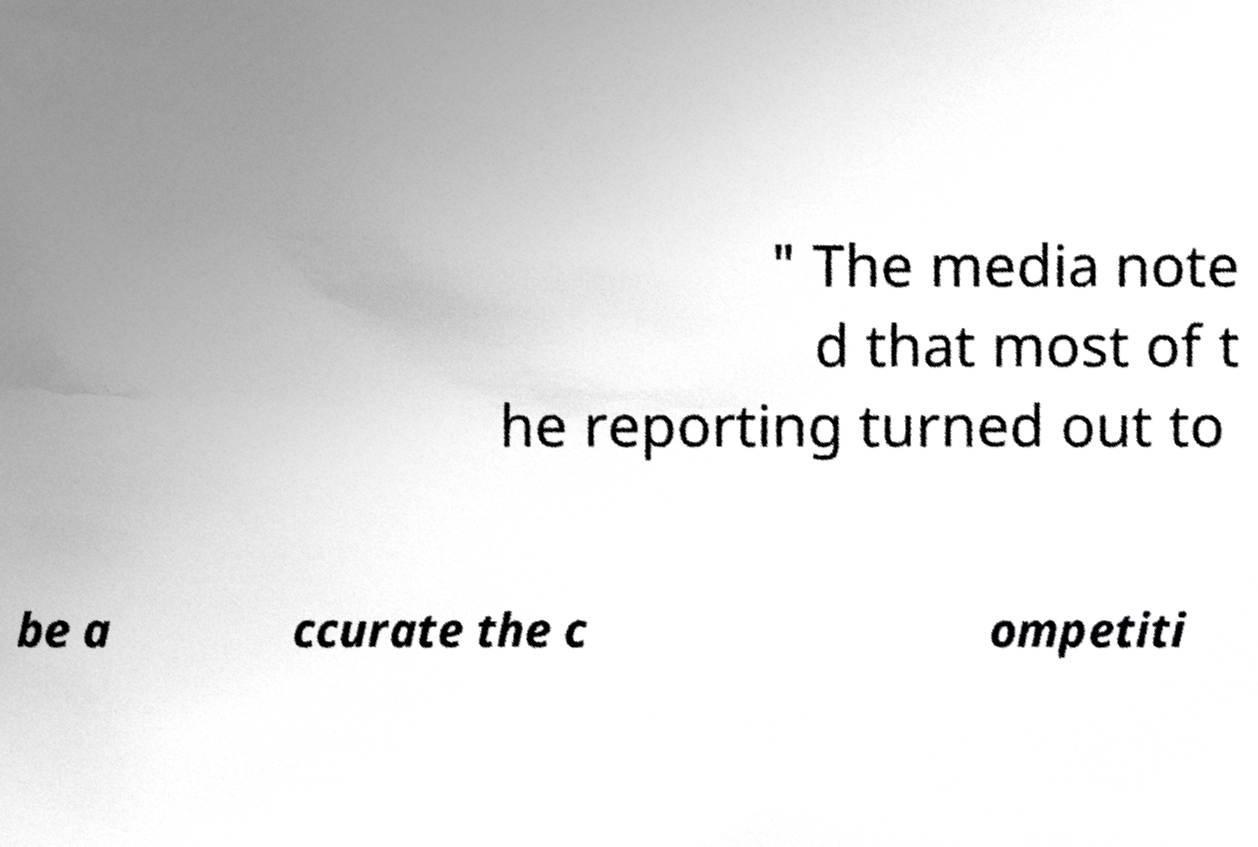For documentation purposes, I need the text within this image transcribed. Could you provide that? " The media note d that most of t he reporting turned out to be a ccurate the c ompetiti 